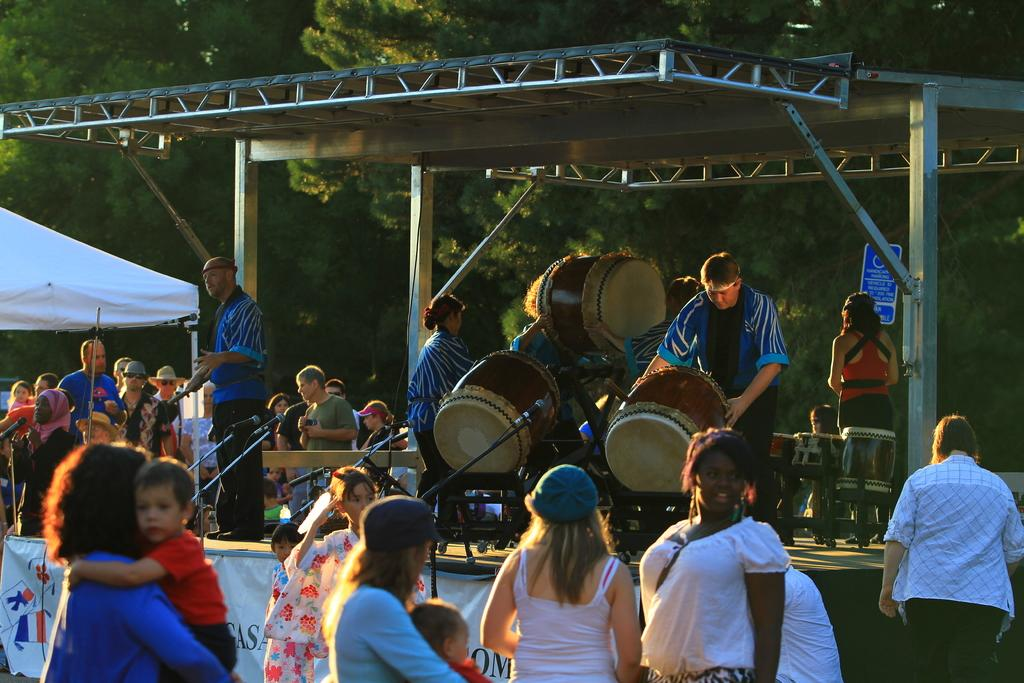What type of natural elements can be seen in the image? There are trees in the image. What else is present in the image besides the trees? There are people standing in the image, as well as musical chairs and microphones. What type of food is being served to the women in the image? There are no women or food present in the image. 